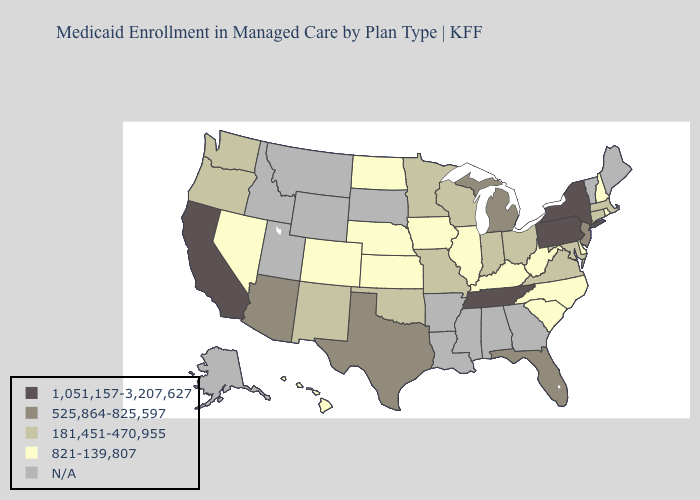What is the highest value in the USA?
Give a very brief answer. 1,051,157-3,207,627. What is the lowest value in states that border Idaho?
Concise answer only. 821-139,807. Does the first symbol in the legend represent the smallest category?
Short answer required. No. What is the lowest value in states that border Connecticut?
Write a very short answer. 821-139,807. Name the states that have a value in the range N/A?
Concise answer only. Alabama, Alaska, Arkansas, Georgia, Idaho, Louisiana, Maine, Mississippi, Montana, South Dakota, Utah, Vermont, Wyoming. What is the lowest value in the West?
Write a very short answer. 821-139,807. What is the value of Ohio?
Give a very brief answer. 181,451-470,955. Does the map have missing data?
Keep it brief. Yes. What is the value of Louisiana?
Concise answer only. N/A. Does California have the highest value in the USA?
Keep it brief. Yes. Name the states that have a value in the range 821-139,807?
Write a very short answer. Colorado, Delaware, Hawaii, Illinois, Iowa, Kansas, Kentucky, Nebraska, Nevada, New Hampshire, North Carolina, North Dakota, Rhode Island, South Carolina, West Virginia. What is the value of Massachusetts?
Answer briefly. 181,451-470,955. Does Pennsylvania have the highest value in the USA?
Concise answer only. Yes. 